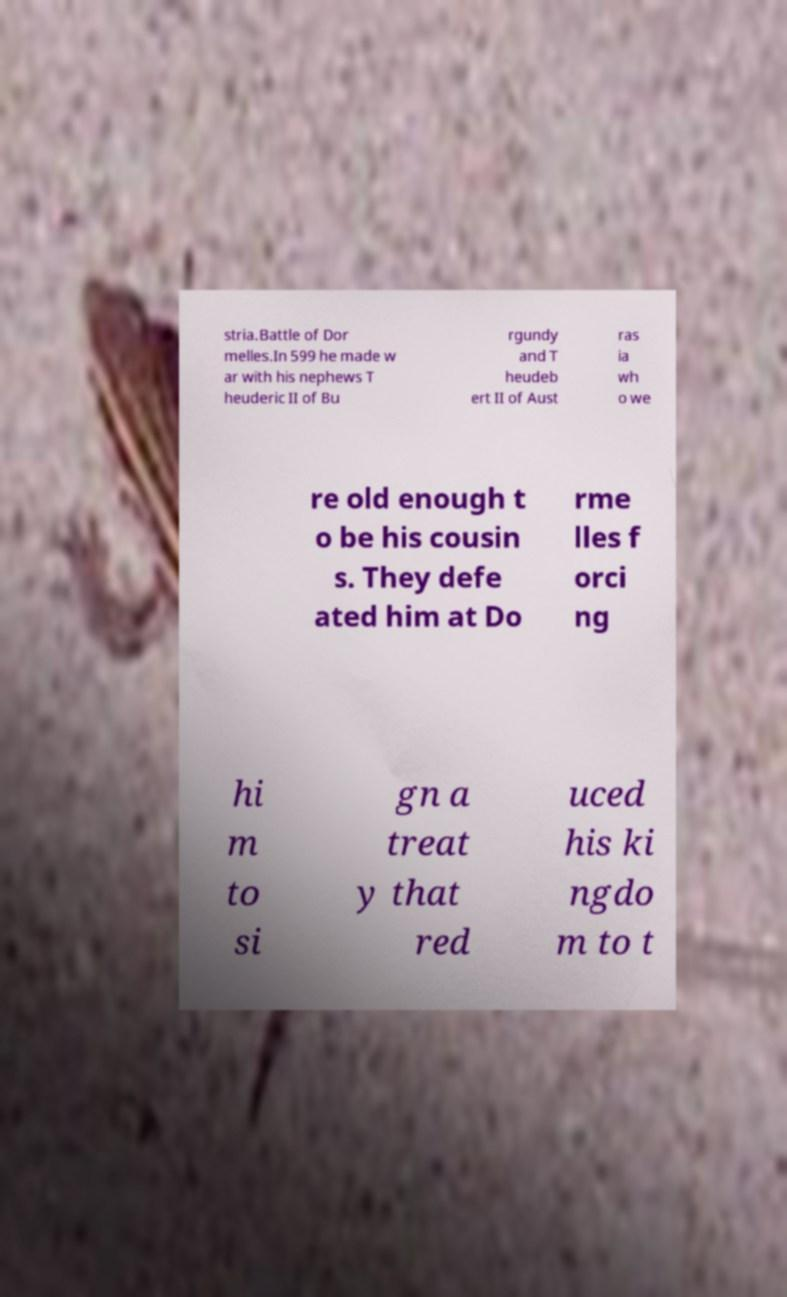Can you accurately transcribe the text from the provided image for me? stria.Battle of Dor melles.In 599 he made w ar with his nephews T heuderic II of Bu rgundy and T heudeb ert II of Aust ras ia wh o we re old enough t o be his cousin s. They defe ated him at Do rme lles f orci ng hi m to si gn a treat y that red uced his ki ngdo m to t 